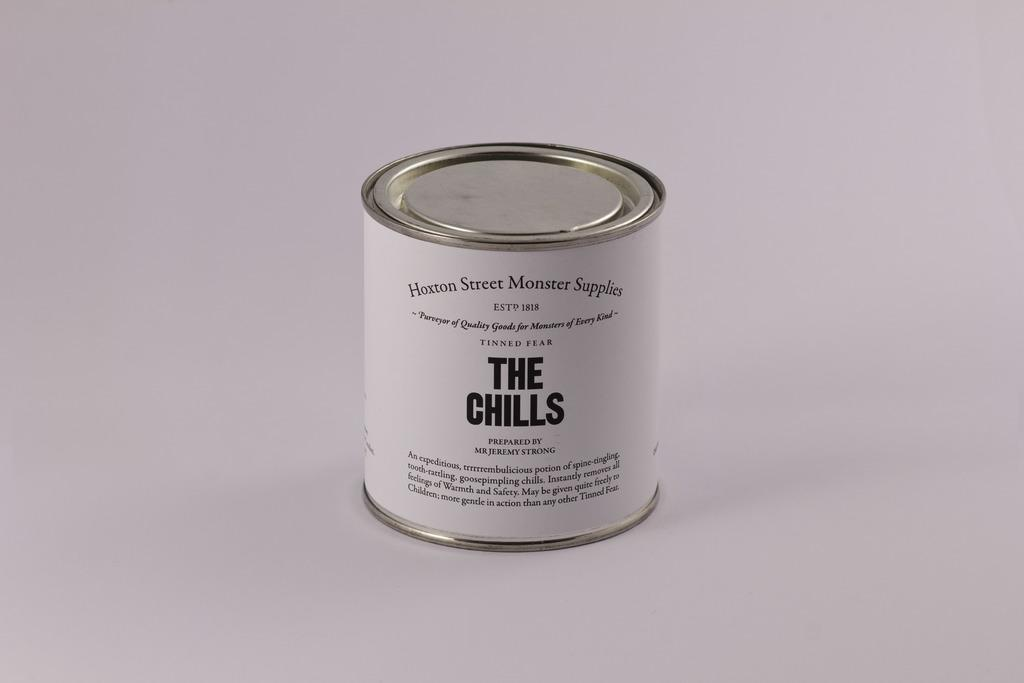<image>
Give a short and clear explanation of the subsequent image. A can with a white label and black letters with the title, "The Chills." 